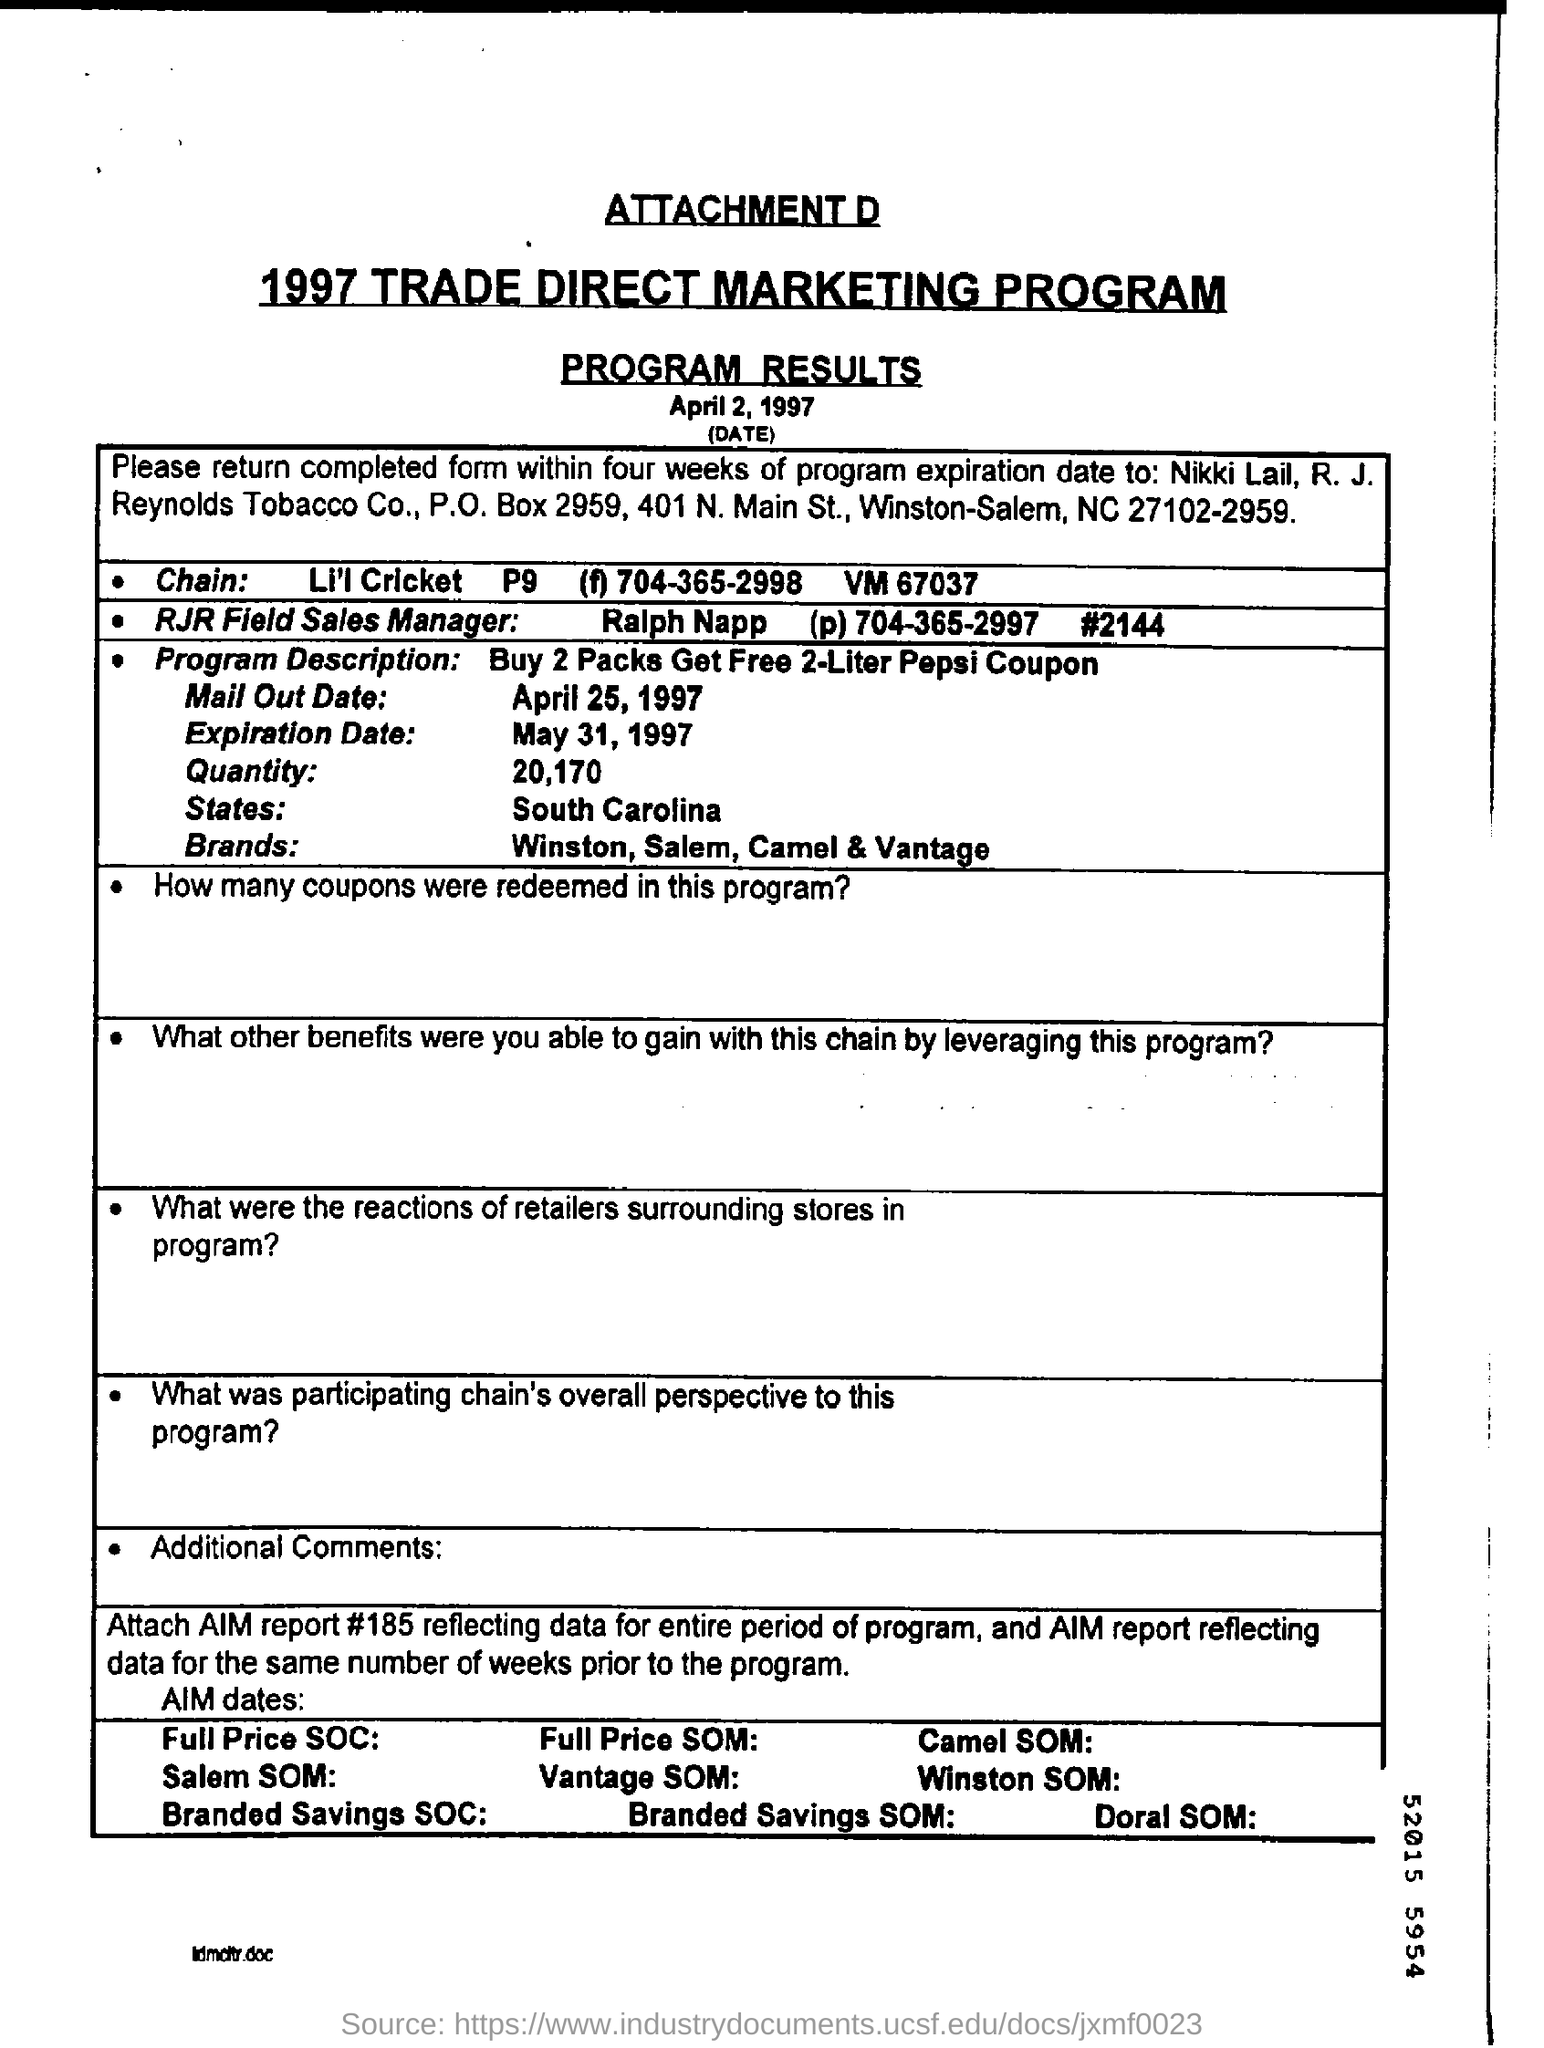The program was applicable for which state?
Offer a terse response. South Carolina. 